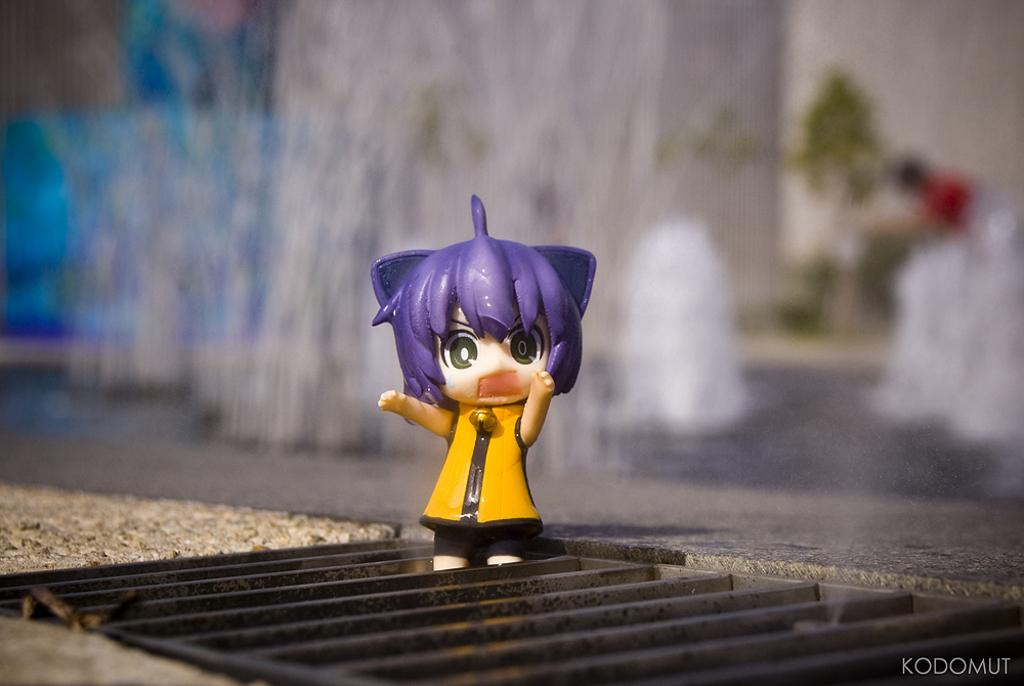What object can be seen in the image? There is a toy in the image. Where is the toy located? The toy is placed on a metal grill. What type of brass instrument is being played in the image? There is no brass instrument or any indication of music being played in the image; it only features a toy on a metal grill. 